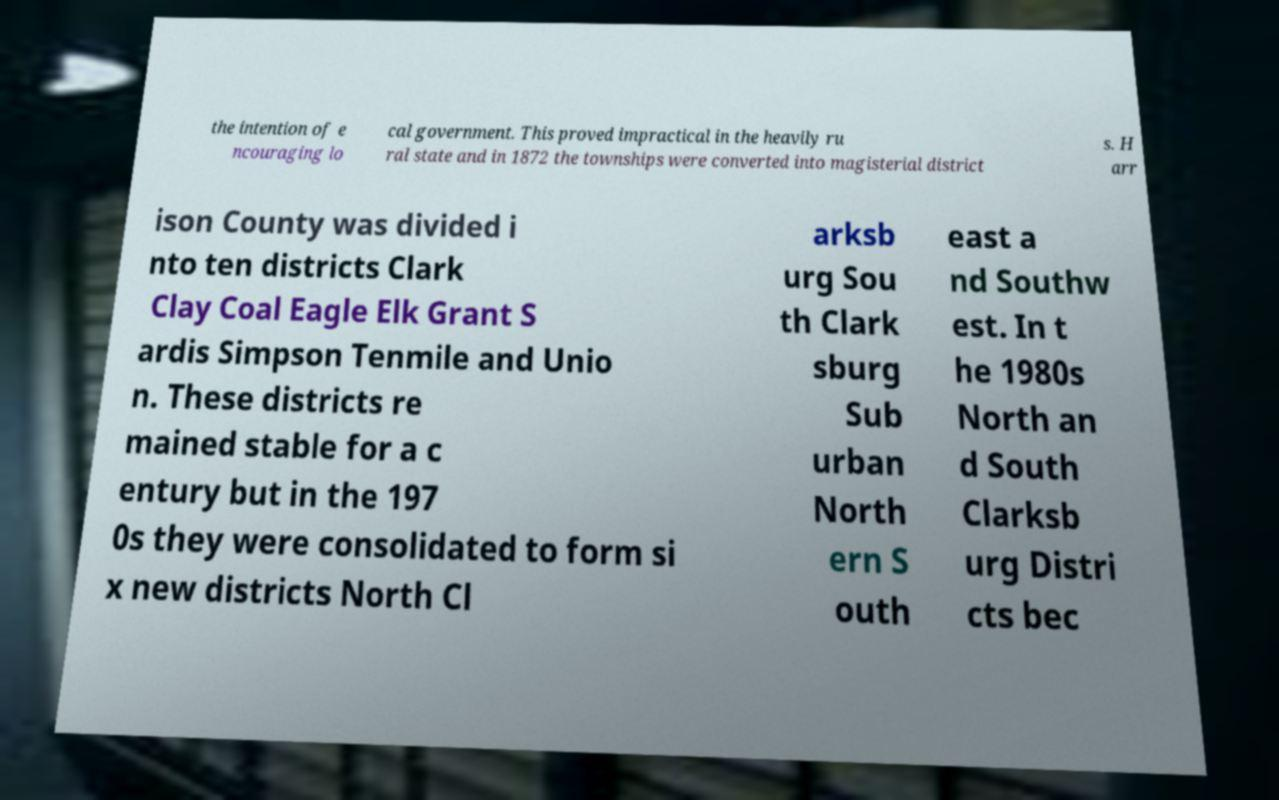Could you assist in decoding the text presented in this image and type it out clearly? the intention of e ncouraging lo cal government. This proved impractical in the heavily ru ral state and in 1872 the townships were converted into magisterial district s. H arr ison County was divided i nto ten districts Clark Clay Coal Eagle Elk Grant S ardis Simpson Tenmile and Unio n. These districts re mained stable for a c entury but in the 197 0s they were consolidated to form si x new districts North Cl arksb urg Sou th Clark sburg Sub urban North ern S outh east a nd Southw est. In t he 1980s North an d South Clarksb urg Distri cts bec 